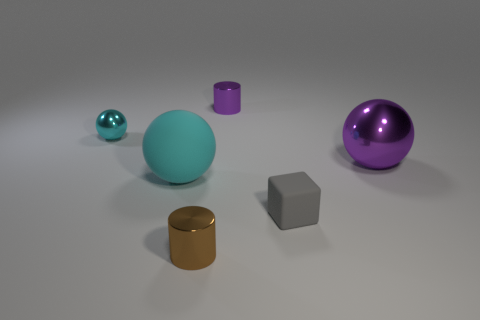What is the material of the purple object that is the same shape as the brown thing?
Ensure brevity in your answer.  Metal. How many metal things are either large purple things or big cyan blocks?
Keep it short and to the point. 1. Is the material of the tiny cylinder that is in front of the gray block the same as the small thing that is to the left of the rubber sphere?
Offer a very short reply. Yes. Are there any gray matte spheres?
Offer a terse response. No. There is a purple metallic object behind the tiny cyan shiny object; is it the same shape as the purple thing in front of the small cyan metal ball?
Give a very brief answer. No. Is there a small purple cylinder made of the same material as the big cyan object?
Keep it short and to the point. No. Is the material of the cylinder that is in front of the tiny cyan sphere the same as the small cyan ball?
Your answer should be very brief. Yes. Are there more tiny matte objects right of the small cube than large matte things in front of the matte sphere?
Give a very brief answer. No. What is the color of the metal sphere that is the same size as the cyan rubber ball?
Your response must be concise. Purple. Are there any other large rubber blocks of the same color as the matte block?
Offer a terse response. No. 